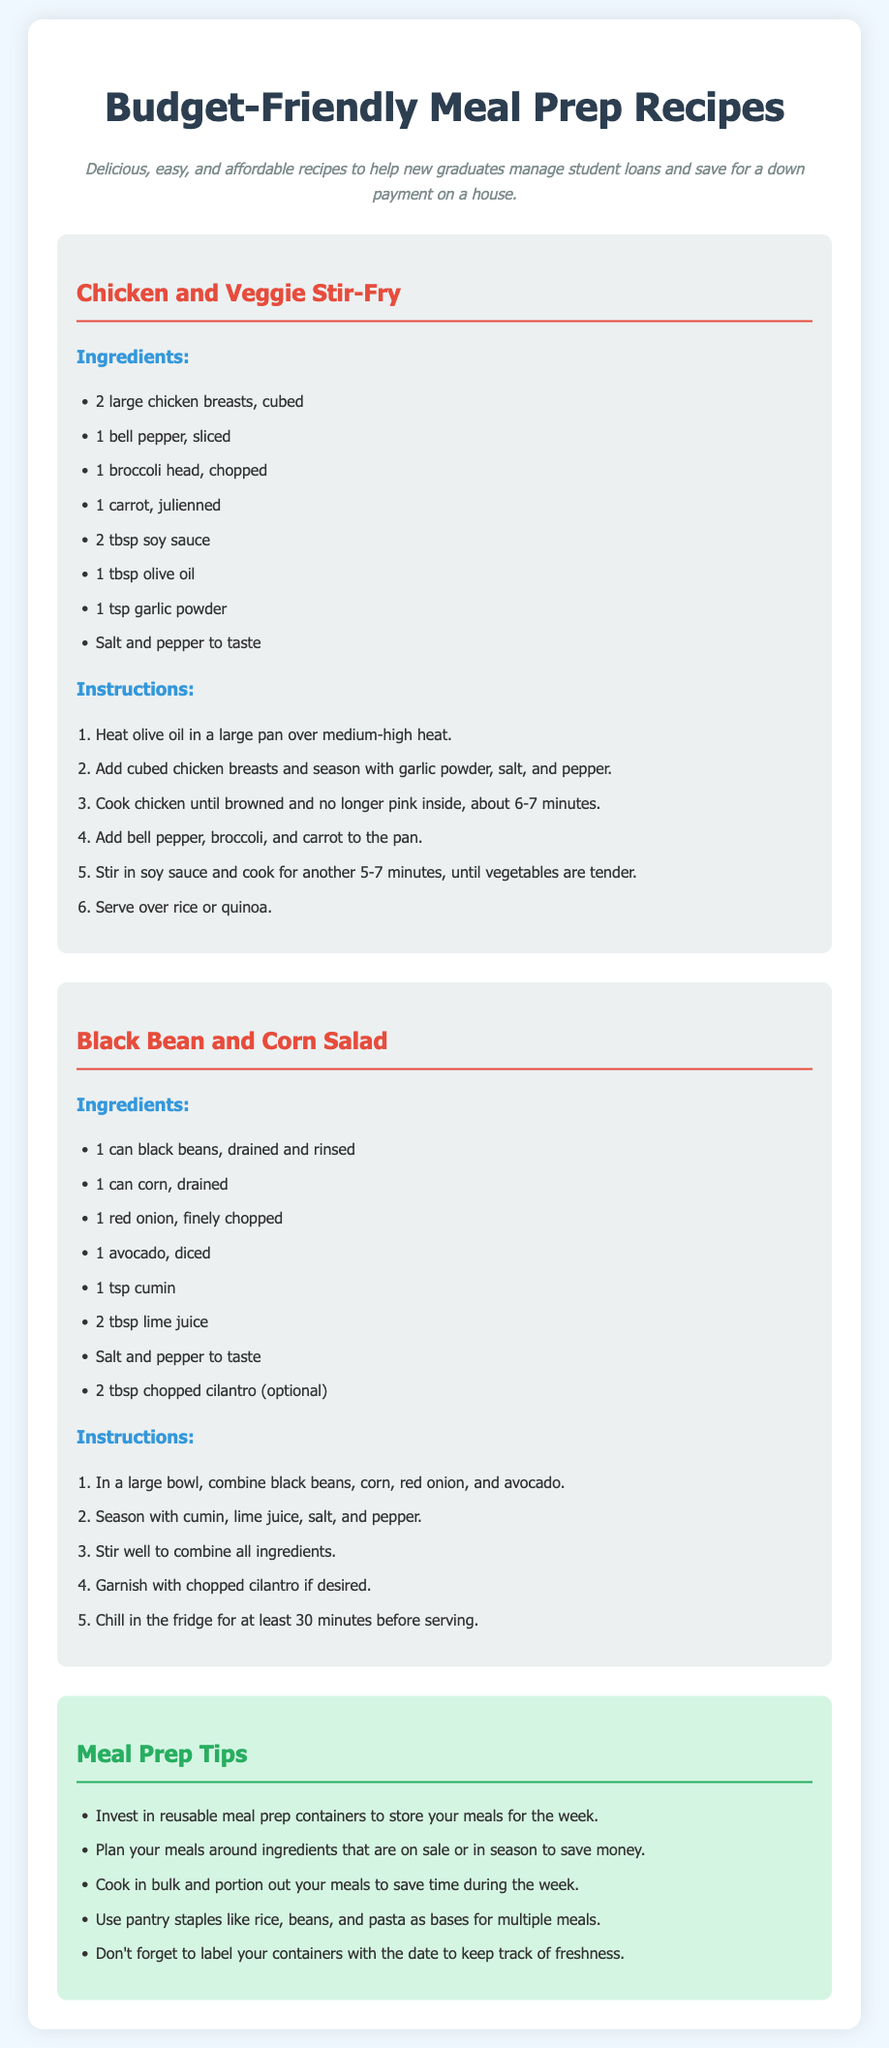What is the title of the document? The title is prominently displayed at the top of the document as "Budget-Friendly Meal Prep Recipes."
Answer: Budget-Friendly Meal Prep Recipes How many chicken breasts are needed for the stir-fry? The recipe specifies "2 large chicken breasts" in the ingredients list.
Answer: 2 large chicken breasts What is the main ingredient in the Black Bean and Corn Salad? The key ingredient is given in the title of the recipe, which is "black beans."
Answer: black beans What cooking method is used for the Chicken and Veggie Stir-Fry? The instructions indicate that the chicken is cooked in a pan, which means the cooking method is sautéing or frying.
Answer: sautéing How long should the Black Bean and Corn Salad chill before serving? The instructions recommend chilling the salad for "at least 30 minutes" before serving.
Answer: at least 30 minutes What type of oil is used in the Chicken and Veggie Stir-Fry? The ingredients list mentions "olive oil" as the type of oil used.
Answer: olive oil Which ingredient is optional in the Black Bean and Corn Salad? The instructions state that chopped cilantro is optional in the recipe.
Answer: chopped cilantro What is one of the tips for meal prep provided in the document? The tips section includes several suggestions, one of which is to "invest in reusable meal prep containers."
Answer: invest in reusable meal prep containers What is the main goal of the document? The description states the goal is to help new graduates "manage student loans and save for a down payment on a house."
Answer: manage student loans and save for a down payment on a house 